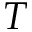<formula> <loc_0><loc_0><loc_500><loc_500>T</formula> 